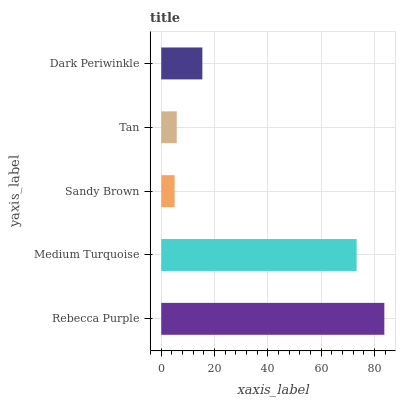Is Sandy Brown the minimum?
Answer yes or no. Yes. Is Rebecca Purple the maximum?
Answer yes or no. Yes. Is Medium Turquoise the minimum?
Answer yes or no. No. Is Medium Turquoise the maximum?
Answer yes or no. No. Is Rebecca Purple greater than Medium Turquoise?
Answer yes or no. Yes. Is Medium Turquoise less than Rebecca Purple?
Answer yes or no. Yes. Is Medium Turquoise greater than Rebecca Purple?
Answer yes or no. No. Is Rebecca Purple less than Medium Turquoise?
Answer yes or no. No. Is Dark Periwinkle the high median?
Answer yes or no. Yes. Is Dark Periwinkle the low median?
Answer yes or no. Yes. Is Tan the high median?
Answer yes or no. No. Is Medium Turquoise the low median?
Answer yes or no. No. 